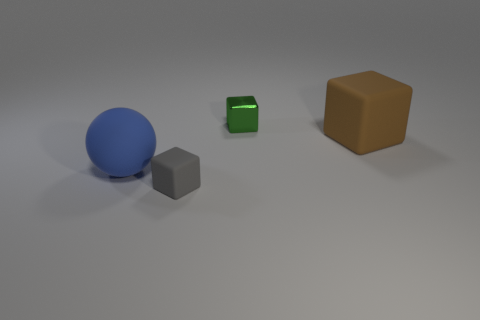Subtract all gray blocks. How many blocks are left? 2 Add 1 spheres. How many objects exist? 5 Subtract all green cubes. How many cubes are left? 2 Subtract 1 cubes. How many cubes are left? 2 Subtract all balls. How many objects are left? 3 Subtract all red blocks. Subtract all cyan cylinders. How many blocks are left? 3 Subtract all brown cubes. How many yellow balls are left? 0 Add 1 small metallic objects. How many small metallic objects are left? 2 Add 3 tiny blue matte cylinders. How many tiny blue matte cylinders exist? 3 Subtract 0 purple cubes. How many objects are left? 4 